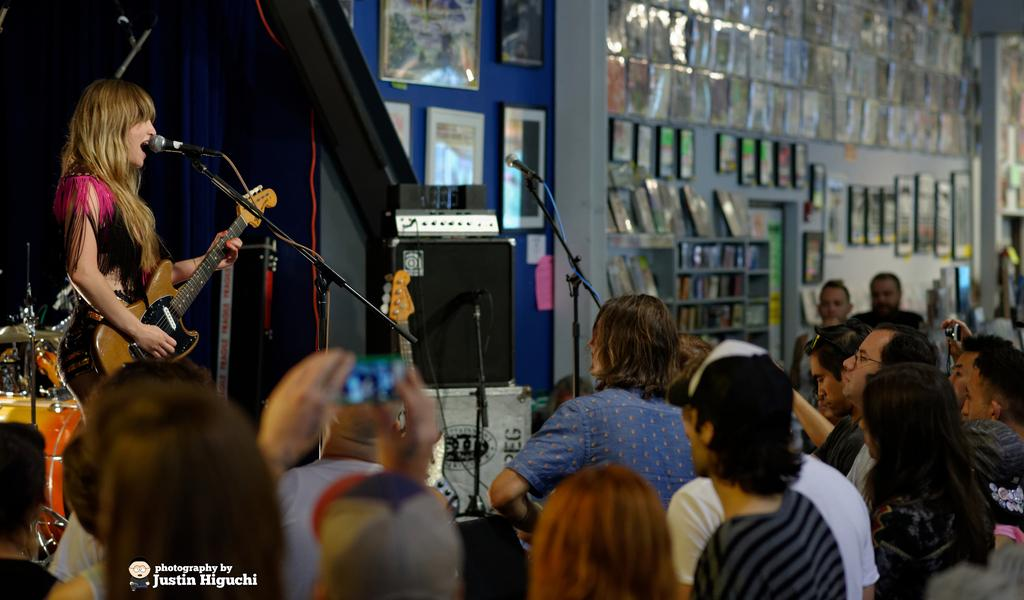What are the people in the image doing? The people in the image are sitting on chairs. What are the people looking at? The people are looking at a woman. What is the woman doing in the image? The woman is standing and holding a guitar in her hand. Can you see any mountains in the image? No, there are no mountains present in the image. What does the woman need to do in order to lead the group? The image does not provide information about the woman leading the group or needing to do anything specific. 